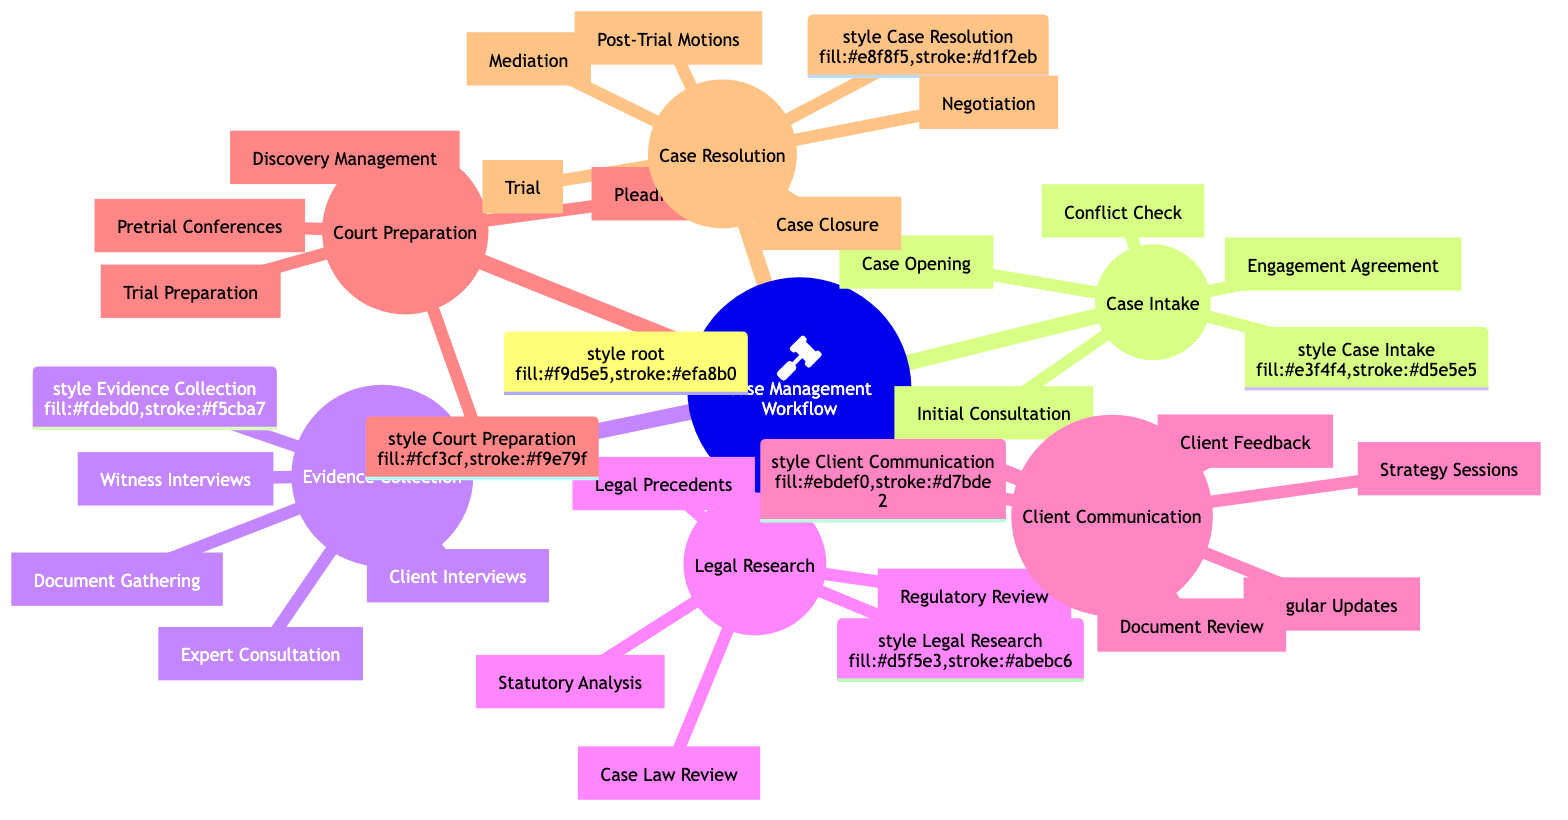What are the main nodes in the diagram? The main nodes are Case Intake, Evidence Collection, Legal Research, Client Communication, Court Preparation, and Case Resolution, which are the primary categories for the case management workflow.
Answer: Case Intake, Evidence Collection, Legal Research, Client Communication, Court Preparation, Case Resolution How many items are listed under Evidence Collection? There are four items listed under Evidence Collection: Client Interviews, Document Gathering, Witness Interviews, and Expert Consultation, which means we count each listed item in this section.
Answer: 4 What is the first step in Case Intake? The first step listed under Case Intake is Initial Consultation, which appears at the top of that node in the diagram.
Answer: Initial Consultation Which phase includes Trial Preparation? Trial Preparation is included in the Court Preparation phase as it is one of the activities outlined within that section of the diagram.
Answer: Court Preparation What action is taken after Negotiation in Case Resolution? After Negotiation in the Case Resolution node, the next action listed is Mediation, indicating it is part of the sequence of activities in that phase.
Answer: Mediation How many steps are there in Client Communication? There are four steps or actions detailed under Client Communication: Regular Updates, Strategy Sessions, Document Review, and Client Feedback, which we can count directly from that node.
Answer: 4 Which two nodes have a similar number of actions listed? Evidence Collection and Client Communication both have four actions listed each, indicating a similarity in their section sizes.
Answer: Evidence Collection, Client Communication Which step involves the client's opinion in the process? The step that involves the client's opinion is Client Feedback, outlining that the client's input is incorporated into the case management.
Answer: Client Feedback What is the last action listed under Case Resolution? The last action listed under Case Resolution is Case Closure, indicating this is the final step in that category.
Answer: Case Closure 